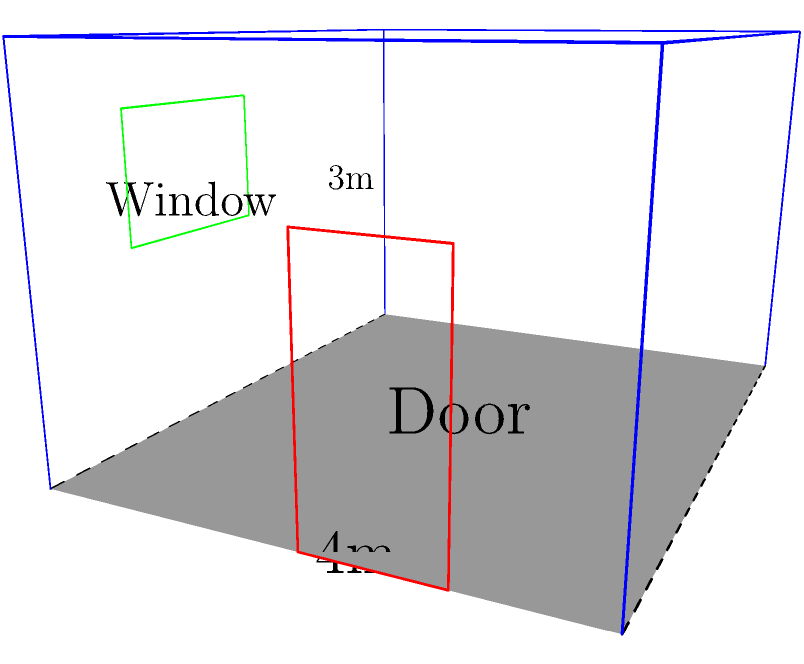Based on the 2D blueprint of a law office shown above, which has been mentally folded into a 3D structure, what is the total surface area of the walls (excluding the floor and ceiling) in square meters? Assume the door and window are part of the wall surface area. To calculate the total surface area of the walls, we need to follow these steps:

1. Identify the dimensions of the office:
   Length (l) = 5m
   Width (w) = 4m
   Height (h) = 3m

2. Calculate the area of each wall:
   Front and back walls: $A_1 = A_2 = l \times h = 5m \times 3m = 15m^2$ each
   Side walls: $A_3 = A_4 = w \times h = 4m \times 3m = 12m^2$ each

3. Sum up the areas of all four walls:
   Total surface area = $A_1 + A_2 + A_3 + A_4$
                      = $15m^2 + 15m^2 + 12m^2 + 12m^2$
                      = $54m^2$

Note: We don't subtract the areas of the door and window as per the question's instruction to include them in the wall surface area.
Answer: $54m^2$ 